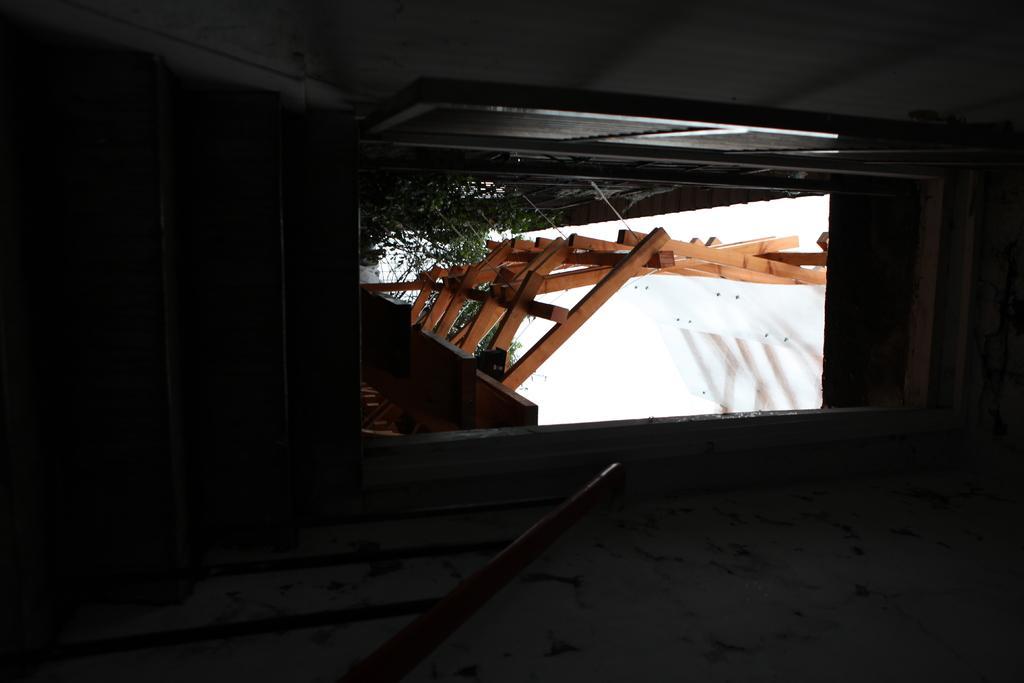Please provide a concise description of this image. In the picture we can see inside the house with some steps and railing to it and on top of the steps we can see a door which is opened and from it we can see some plants and some wooden sticks. 